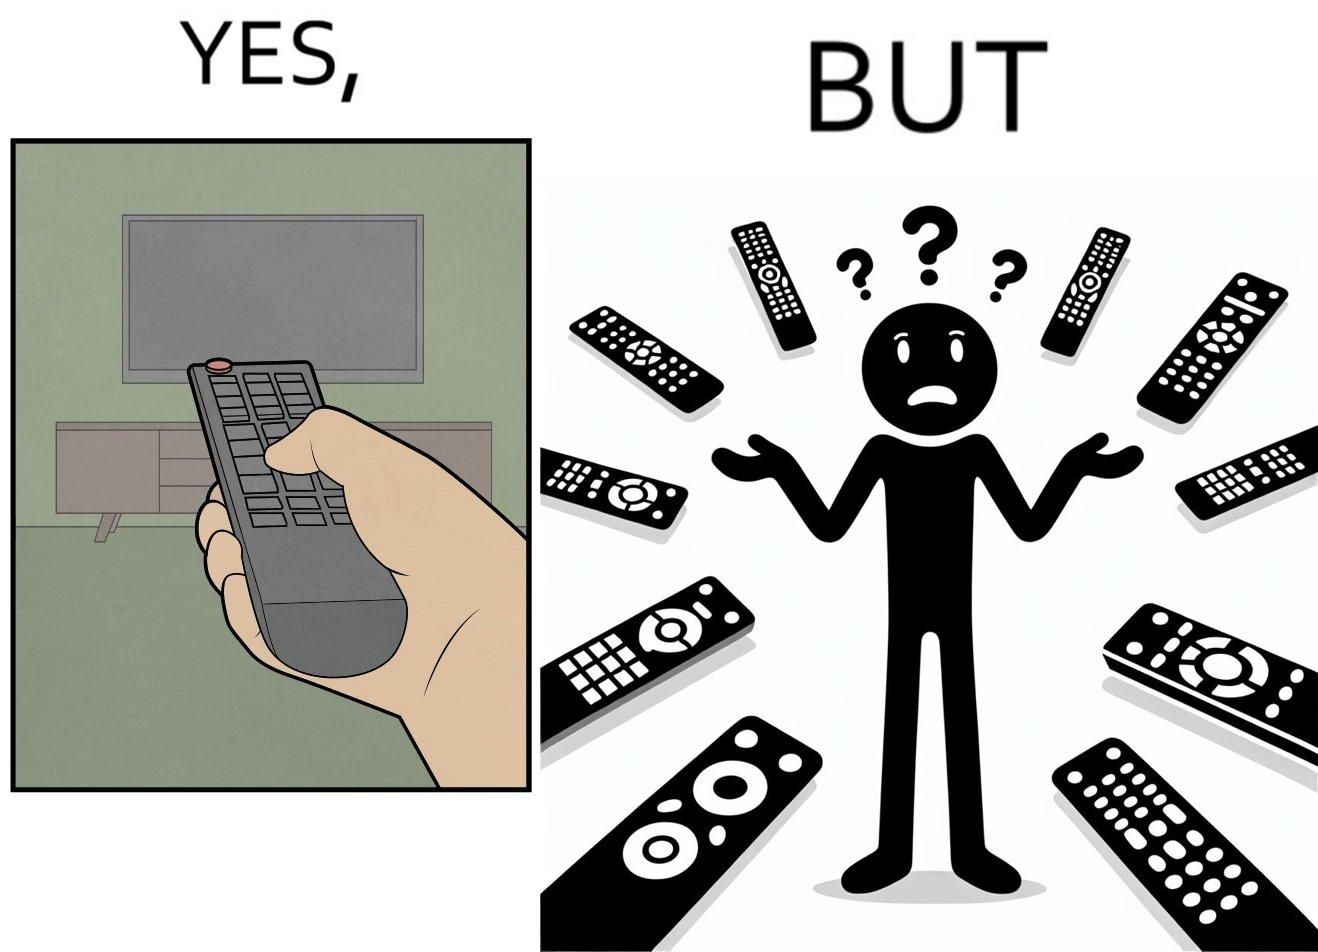Does this image contain satire or humor? Yes, this image is satirical. 